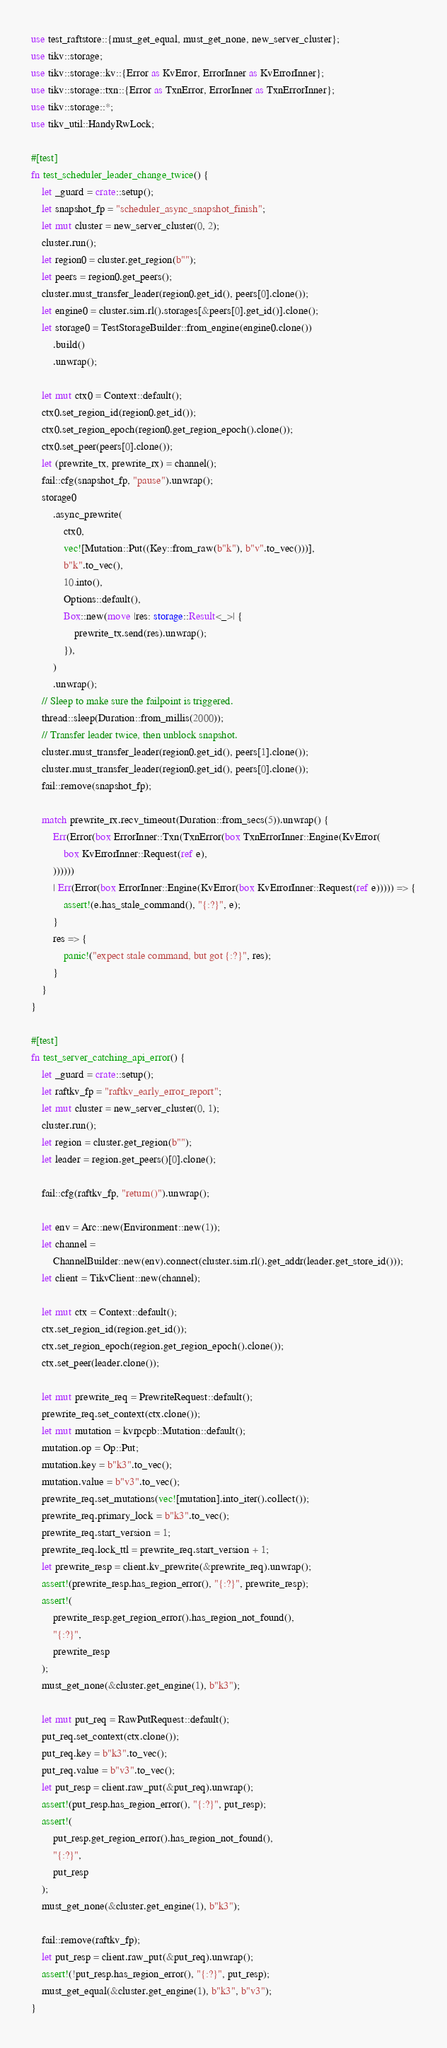<code> <loc_0><loc_0><loc_500><loc_500><_Rust_>use test_raftstore::{must_get_equal, must_get_none, new_server_cluster};
use tikv::storage;
use tikv::storage::kv::{Error as KvError, ErrorInner as KvErrorInner};
use tikv::storage::txn::{Error as TxnError, ErrorInner as TxnErrorInner};
use tikv::storage::*;
use tikv_util::HandyRwLock;

#[test]
fn test_scheduler_leader_change_twice() {
    let _guard = crate::setup();
    let snapshot_fp = "scheduler_async_snapshot_finish";
    let mut cluster = new_server_cluster(0, 2);
    cluster.run();
    let region0 = cluster.get_region(b"");
    let peers = region0.get_peers();
    cluster.must_transfer_leader(region0.get_id(), peers[0].clone());
    let engine0 = cluster.sim.rl().storages[&peers[0].get_id()].clone();
    let storage0 = TestStorageBuilder::from_engine(engine0.clone())
        .build()
        .unwrap();

    let mut ctx0 = Context::default();
    ctx0.set_region_id(region0.get_id());
    ctx0.set_region_epoch(region0.get_region_epoch().clone());
    ctx0.set_peer(peers[0].clone());
    let (prewrite_tx, prewrite_rx) = channel();
    fail::cfg(snapshot_fp, "pause").unwrap();
    storage0
        .async_prewrite(
            ctx0,
            vec![Mutation::Put((Key::from_raw(b"k"), b"v".to_vec()))],
            b"k".to_vec(),
            10.into(),
            Options::default(),
            Box::new(move |res: storage::Result<_>| {
                prewrite_tx.send(res).unwrap();
            }),
        )
        .unwrap();
    // Sleep to make sure the failpoint is triggered.
    thread::sleep(Duration::from_millis(2000));
    // Transfer leader twice, then unblock snapshot.
    cluster.must_transfer_leader(region0.get_id(), peers[1].clone());
    cluster.must_transfer_leader(region0.get_id(), peers[0].clone());
    fail::remove(snapshot_fp);

    match prewrite_rx.recv_timeout(Duration::from_secs(5)).unwrap() {
        Err(Error(box ErrorInner::Txn(TxnError(box TxnErrorInner::Engine(KvError(
            box KvErrorInner::Request(ref e),
        ))))))
        | Err(Error(box ErrorInner::Engine(KvError(box KvErrorInner::Request(ref e))))) => {
            assert!(e.has_stale_command(), "{:?}", e);
        }
        res => {
            panic!("expect stale command, but got {:?}", res);
        }
    }
}

#[test]
fn test_server_catching_api_error() {
    let _guard = crate::setup();
    let raftkv_fp = "raftkv_early_error_report";
    let mut cluster = new_server_cluster(0, 1);
    cluster.run();
    let region = cluster.get_region(b"");
    let leader = region.get_peers()[0].clone();

    fail::cfg(raftkv_fp, "return()").unwrap();

    let env = Arc::new(Environment::new(1));
    let channel =
        ChannelBuilder::new(env).connect(cluster.sim.rl().get_addr(leader.get_store_id()));
    let client = TikvClient::new(channel);

    let mut ctx = Context::default();
    ctx.set_region_id(region.get_id());
    ctx.set_region_epoch(region.get_region_epoch().clone());
    ctx.set_peer(leader.clone());

    let mut prewrite_req = PrewriteRequest::default();
    prewrite_req.set_context(ctx.clone());
    let mut mutation = kvrpcpb::Mutation::default();
    mutation.op = Op::Put;
    mutation.key = b"k3".to_vec();
    mutation.value = b"v3".to_vec();
    prewrite_req.set_mutations(vec![mutation].into_iter().collect());
    prewrite_req.primary_lock = b"k3".to_vec();
    prewrite_req.start_version = 1;
    prewrite_req.lock_ttl = prewrite_req.start_version + 1;
    let prewrite_resp = client.kv_prewrite(&prewrite_req).unwrap();
    assert!(prewrite_resp.has_region_error(), "{:?}", prewrite_resp);
    assert!(
        prewrite_resp.get_region_error().has_region_not_found(),
        "{:?}",
        prewrite_resp
    );
    must_get_none(&cluster.get_engine(1), b"k3");

    let mut put_req = RawPutRequest::default();
    put_req.set_context(ctx.clone());
    put_req.key = b"k3".to_vec();
    put_req.value = b"v3".to_vec();
    let put_resp = client.raw_put(&put_req).unwrap();
    assert!(put_resp.has_region_error(), "{:?}", put_resp);
    assert!(
        put_resp.get_region_error().has_region_not_found(),
        "{:?}",
        put_resp
    );
    must_get_none(&cluster.get_engine(1), b"k3");

    fail::remove(raftkv_fp);
    let put_resp = client.raw_put(&put_req).unwrap();
    assert!(!put_resp.has_region_error(), "{:?}", put_resp);
    must_get_equal(&cluster.get_engine(1), b"k3", b"v3");
}
</code> 